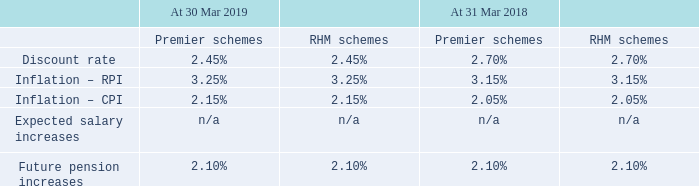At the balance sheet date, the combined principal accounting assumptions were as follows:
For the smaller overseas schemes the discount rate used was 1.50% (2017/18: 1.80%) and future pension increases were 1.30% (2017/18: 1.45%).
At 30 March 2019 and 31 March 2018, the discount rate was derived based on a bond yield curve expanded to also include bonds rated AA by one credit agency (and which might for example be rated A or AAA by other agencies).
What was the discount rate used for smaller overseas schemes in 2018/19? 1.50%. What was the discount rate at 30 March 2019 based on? A bond yield curve expanded to also include bonds rated aa by one credit agency (and which might for example be rated a or aaa by other agencies). What was the discount rate at 30 March 2019 for premier schemes?
Answer scale should be: percent. 2.45. What is the change in the premier schemes discount rate from 2018 to 2019?
Answer scale should be: percent. 2.45% - 2.70%
Answer: -0.25. What is the average inflation RPI for premier schemes?
Answer scale should be: percent. (3.25% + 3.15%) / 2
Answer: 3.2. What is the change in the inflation - CPI for RHm schemes from 2018 to 2019?
Answer scale should be: percent. 2.15% - 2.05%
Answer: 0.1. 